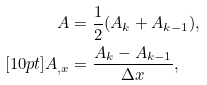<formula> <loc_0><loc_0><loc_500><loc_500>A & = \frac { 1 } { 2 } ( A _ { k } + A _ { k - 1 } ) , \\ [ 1 0 p t ] A _ { , x } & = \frac { A _ { k } - A _ { k - 1 } } { \Delta x } ,</formula> 